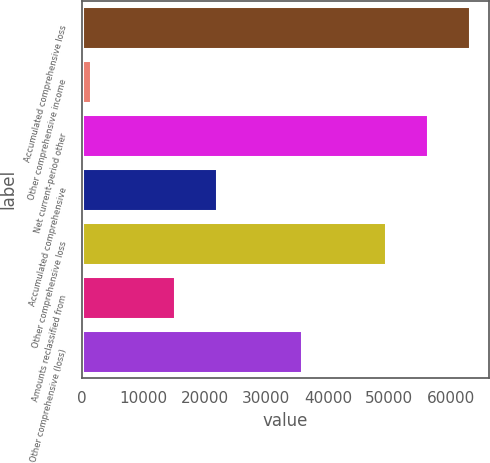Convert chart to OTSL. <chart><loc_0><loc_0><loc_500><loc_500><bar_chart><fcel>Accumulated comprehensive loss<fcel>Other comprehensive income<fcel>Net current-period other<fcel>Accumulated comprehensive<fcel>Other comprehensive loss<fcel>Amounts reclassified from<fcel>Other comprehensive (loss)<nl><fcel>63074.6<fcel>1529<fcel>56236.2<fcel>22044.2<fcel>49397.8<fcel>15205.8<fcel>35721<nl></chart> 